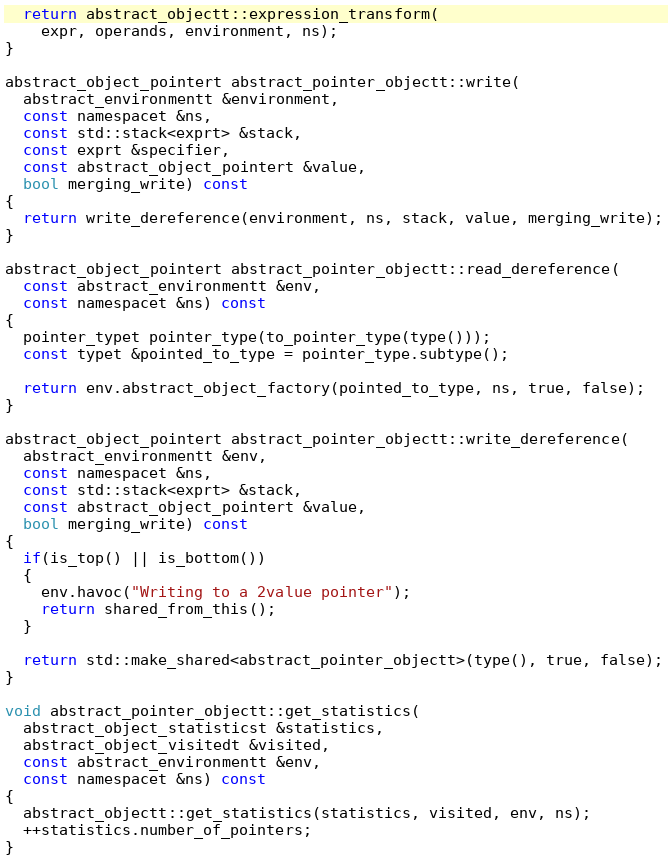Convert code to text. <code><loc_0><loc_0><loc_500><loc_500><_C++_>
  return abstract_objectt::expression_transform(
    expr, operands, environment, ns);
}

abstract_object_pointert abstract_pointer_objectt::write(
  abstract_environmentt &environment,
  const namespacet &ns,
  const std::stack<exprt> &stack,
  const exprt &specifier,
  const abstract_object_pointert &value,
  bool merging_write) const
{
  return write_dereference(environment, ns, stack, value, merging_write);
}

abstract_object_pointert abstract_pointer_objectt::read_dereference(
  const abstract_environmentt &env,
  const namespacet &ns) const
{
  pointer_typet pointer_type(to_pointer_type(type()));
  const typet &pointed_to_type = pointer_type.subtype();

  return env.abstract_object_factory(pointed_to_type, ns, true, false);
}

abstract_object_pointert abstract_pointer_objectt::write_dereference(
  abstract_environmentt &env,
  const namespacet &ns,
  const std::stack<exprt> &stack,
  const abstract_object_pointert &value,
  bool merging_write) const
{
  if(is_top() || is_bottom())
  {
    env.havoc("Writing to a 2value pointer");
    return shared_from_this();
  }

  return std::make_shared<abstract_pointer_objectt>(type(), true, false);
}

void abstract_pointer_objectt::get_statistics(
  abstract_object_statisticst &statistics,
  abstract_object_visitedt &visited,
  const abstract_environmentt &env,
  const namespacet &ns) const
{
  abstract_objectt::get_statistics(statistics, visited, env, ns);
  ++statistics.number_of_pointers;
}
</code> 